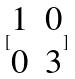<formula> <loc_0><loc_0><loc_500><loc_500>[ \begin{matrix} 1 & 0 \\ 0 & 3 \end{matrix} ]</formula> 